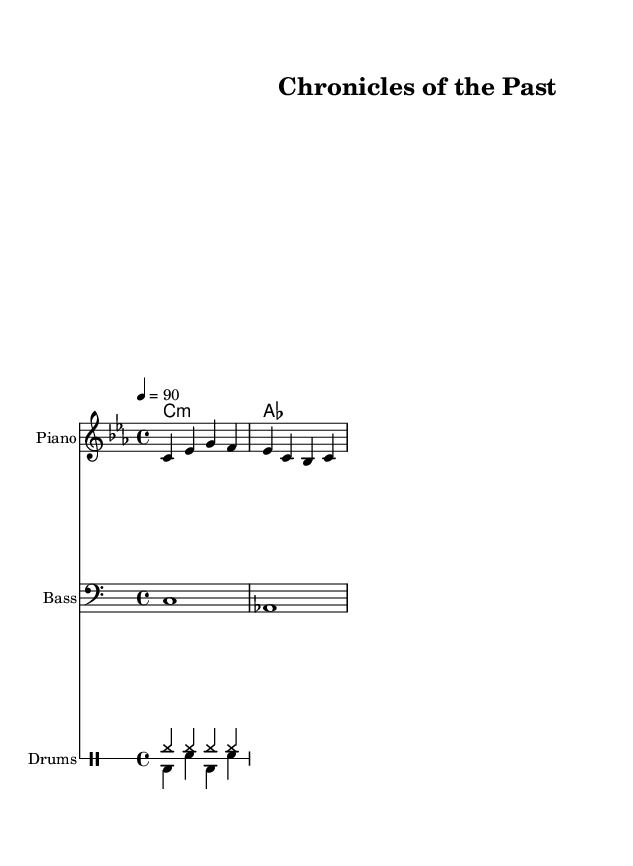What is the key signature of this music? The key signature indicated in the score is C minor, which contains three flats: B flat, E flat, and A flat. This can be identified by looking at the key signature at the beginning of the staff.
Answer: C minor What is the time signature of this music? The time signature shown at the beginning is 4/4, which means there are four beats in each measure and a quarter note receives one beat. This is noted at the start of the score right after the key signature.
Answer: 4/4 What is the tempo marking for this piece? The tempo marking shown in the score is "4 = 90," indicating that there are 90 quarter note beats per minute. This is located right at the beginning, alongside the time signature.
Answer: 90 How many measures are there in the melody section? The melody section consists of only 2 measures, which can be determined by counting the vertical lines (bar lines) that separate the measures in the melody staff.
Answer: 2 What is the instrument indicated for the harmony part? The harmony part is labeled as "ChordNames," which indicates that it is intended to be played with a harmonic instrument such as a piano or guitar. This is shown in the staff's designation.
Answer: ChordNames What type of rhythmic pattern is featured in the drum section? The drum section has a combination of hi-hat and bass drum patterns, typical for Hip Hop music. The structured use of these elements reflects the rhythmic and percussive style characteristic of Hip Hop. Both patterns are visually distinguishable in the drum staff as they alternate between the hi-hat and bass-drum markings.
Answer: Hi-hat and bass drum 